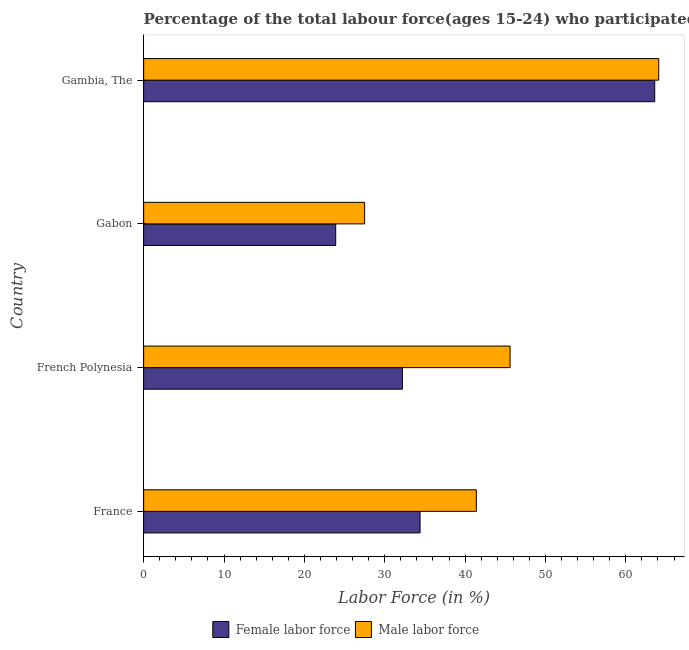Are the number of bars per tick equal to the number of legend labels?
Your answer should be compact. Yes. Are the number of bars on each tick of the Y-axis equal?
Your answer should be compact. Yes. How many bars are there on the 4th tick from the bottom?
Offer a terse response. 2. What is the label of the 3rd group of bars from the top?
Offer a very short reply. French Polynesia. What is the percentage of female labor force in France?
Your response must be concise. 34.4. Across all countries, what is the maximum percentage of female labor force?
Make the answer very short. 63.6. Across all countries, what is the minimum percentage of female labor force?
Offer a very short reply. 23.9. In which country was the percentage of male labour force maximum?
Your response must be concise. Gambia, The. In which country was the percentage of female labor force minimum?
Make the answer very short. Gabon. What is the total percentage of male labour force in the graph?
Make the answer very short. 178.6. What is the difference between the percentage of male labour force in French Polynesia and that in Gabon?
Offer a terse response. 18.1. What is the difference between the percentage of male labour force in Gambia, The and the percentage of female labor force in Gabon?
Your response must be concise. 40.2. What is the average percentage of female labor force per country?
Keep it short and to the point. 38.52. What is the difference between the percentage of female labor force and percentage of male labour force in France?
Give a very brief answer. -7. In how many countries, is the percentage of female labor force greater than 58 %?
Make the answer very short. 1. What is the ratio of the percentage of male labour force in France to that in French Polynesia?
Give a very brief answer. 0.91. Is the percentage of male labour force in France less than that in Gambia, The?
Your answer should be very brief. Yes. Is the difference between the percentage of male labour force in French Polynesia and Gabon greater than the difference between the percentage of female labor force in French Polynesia and Gabon?
Your response must be concise. Yes. What is the difference between the highest and the second highest percentage of male labour force?
Keep it short and to the point. 18.5. What is the difference between the highest and the lowest percentage of male labour force?
Provide a succinct answer. 36.6. What does the 2nd bar from the top in Gabon represents?
Give a very brief answer. Female labor force. What does the 2nd bar from the bottom in France represents?
Provide a short and direct response. Male labor force. How many bars are there?
Your response must be concise. 8. How many countries are there in the graph?
Offer a very short reply. 4. What is the difference between two consecutive major ticks on the X-axis?
Offer a terse response. 10. How are the legend labels stacked?
Your answer should be compact. Horizontal. What is the title of the graph?
Offer a terse response. Percentage of the total labour force(ages 15-24) who participated in production in 2013. What is the label or title of the X-axis?
Offer a terse response. Labor Force (in %). What is the label or title of the Y-axis?
Offer a terse response. Country. What is the Labor Force (in %) of Female labor force in France?
Your answer should be compact. 34.4. What is the Labor Force (in %) in Male labor force in France?
Keep it short and to the point. 41.4. What is the Labor Force (in %) in Female labor force in French Polynesia?
Give a very brief answer. 32.2. What is the Labor Force (in %) of Male labor force in French Polynesia?
Your answer should be very brief. 45.6. What is the Labor Force (in %) of Female labor force in Gabon?
Provide a succinct answer. 23.9. What is the Labor Force (in %) in Male labor force in Gabon?
Provide a succinct answer. 27.5. What is the Labor Force (in %) of Female labor force in Gambia, The?
Give a very brief answer. 63.6. What is the Labor Force (in %) in Male labor force in Gambia, The?
Ensure brevity in your answer.  64.1. Across all countries, what is the maximum Labor Force (in %) in Female labor force?
Offer a terse response. 63.6. Across all countries, what is the maximum Labor Force (in %) in Male labor force?
Ensure brevity in your answer.  64.1. Across all countries, what is the minimum Labor Force (in %) in Female labor force?
Keep it short and to the point. 23.9. Across all countries, what is the minimum Labor Force (in %) of Male labor force?
Provide a short and direct response. 27.5. What is the total Labor Force (in %) in Female labor force in the graph?
Provide a succinct answer. 154.1. What is the total Labor Force (in %) of Male labor force in the graph?
Ensure brevity in your answer.  178.6. What is the difference between the Labor Force (in %) in Male labor force in France and that in French Polynesia?
Ensure brevity in your answer.  -4.2. What is the difference between the Labor Force (in %) in Female labor force in France and that in Gabon?
Offer a very short reply. 10.5. What is the difference between the Labor Force (in %) of Male labor force in France and that in Gabon?
Provide a short and direct response. 13.9. What is the difference between the Labor Force (in %) of Female labor force in France and that in Gambia, The?
Keep it short and to the point. -29.2. What is the difference between the Labor Force (in %) in Male labor force in France and that in Gambia, The?
Ensure brevity in your answer.  -22.7. What is the difference between the Labor Force (in %) of Female labor force in French Polynesia and that in Gabon?
Your answer should be very brief. 8.3. What is the difference between the Labor Force (in %) of Male labor force in French Polynesia and that in Gabon?
Offer a terse response. 18.1. What is the difference between the Labor Force (in %) in Female labor force in French Polynesia and that in Gambia, The?
Make the answer very short. -31.4. What is the difference between the Labor Force (in %) of Male labor force in French Polynesia and that in Gambia, The?
Offer a very short reply. -18.5. What is the difference between the Labor Force (in %) of Female labor force in Gabon and that in Gambia, The?
Your response must be concise. -39.7. What is the difference between the Labor Force (in %) in Male labor force in Gabon and that in Gambia, The?
Offer a terse response. -36.6. What is the difference between the Labor Force (in %) of Female labor force in France and the Labor Force (in %) of Male labor force in French Polynesia?
Ensure brevity in your answer.  -11.2. What is the difference between the Labor Force (in %) in Female labor force in France and the Labor Force (in %) in Male labor force in Gabon?
Offer a terse response. 6.9. What is the difference between the Labor Force (in %) of Female labor force in France and the Labor Force (in %) of Male labor force in Gambia, The?
Your response must be concise. -29.7. What is the difference between the Labor Force (in %) of Female labor force in French Polynesia and the Labor Force (in %) of Male labor force in Gambia, The?
Keep it short and to the point. -31.9. What is the difference between the Labor Force (in %) of Female labor force in Gabon and the Labor Force (in %) of Male labor force in Gambia, The?
Provide a short and direct response. -40.2. What is the average Labor Force (in %) in Female labor force per country?
Keep it short and to the point. 38.52. What is the average Labor Force (in %) in Male labor force per country?
Keep it short and to the point. 44.65. What is the difference between the Labor Force (in %) of Female labor force and Labor Force (in %) of Male labor force in France?
Your response must be concise. -7. What is the ratio of the Labor Force (in %) of Female labor force in France to that in French Polynesia?
Provide a short and direct response. 1.07. What is the ratio of the Labor Force (in %) in Male labor force in France to that in French Polynesia?
Your response must be concise. 0.91. What is the ratio of the Labor Force (in %) of Female labor force in France to that in Gabon?
Ensure brevity in your answer.  1.44. What is the ratio of the Labor Force (in %) of Male labor force in France to that in Gabon?
Provide a succinct answer. 1.51. What is the ratio of the Labor Force (in %) of Female labor force in France to that in Gambia, The?
Ensure brevity in your answer.  0.54. What is the ratio of the Labor Force (in %) of Male labor force in France to that in Gambia, The?
Provide a short and direct response. 0.65. What is the ratio of the Labor Force (in %) of Female labor force in French Polynesia to that in Gabon?
Make the answer very short. 1.35. What is the ratio of the Labor Force (in %) in Male labor force in French Polynesia to that in Gabon?
Make the answer very short. 1.66. What is the ratio of the Labor Force (in %) of Female labor force in French Polynesia to that in Gambia, The?
Provide a succinct answer. 0.51. What is the ratio of the Labor Force (in %) in Male labor force in French Polynesia to that in Gambia, The?
Ensure brevity in your answer.  0.71. What is the ratio of the Labor Force (in %) in Female labor force in Gabon to that in Gambia, The?
Provide a short and direct response. 0.38. What is the ratio of the Labor Force (in %) of Male labor force in Gabon to that in Gambia, The?
Provide a succinct answer. 0.43. What is the difference between the highest and the second highest Labor Force (in %) of Female labor force?
Your answer should be very brief. 29.2. What is the difference between the highest and the lowest Labor Force (in %) in Female labor force?
Give a very brief answer. 39.7. What is the difference between the highest and the lowest Labor Force (in %) of Male labor force?
Your answer should be very brief. 36.6. 